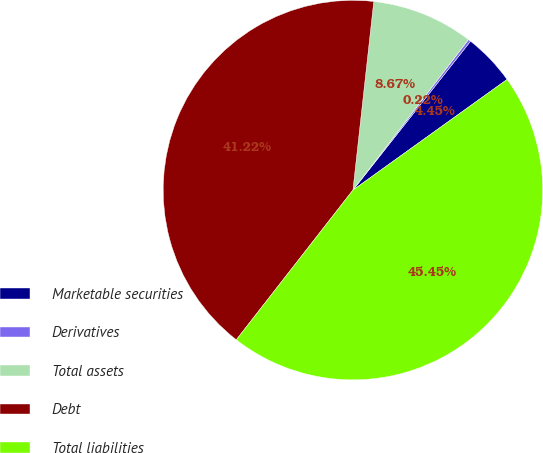<chart> <loc_0><loc_0><loc_500><loc_500><pie_chart><fcel>Marketable securities<fcel>Derivatives<fcel>Total assets<fcel>Debt<fcel>Total liabilities<nl><fcel>4.45%<fcel>0.22%<fcel>8.67%<fcel>41.22%<fcel>45.45%<nl></chart> 